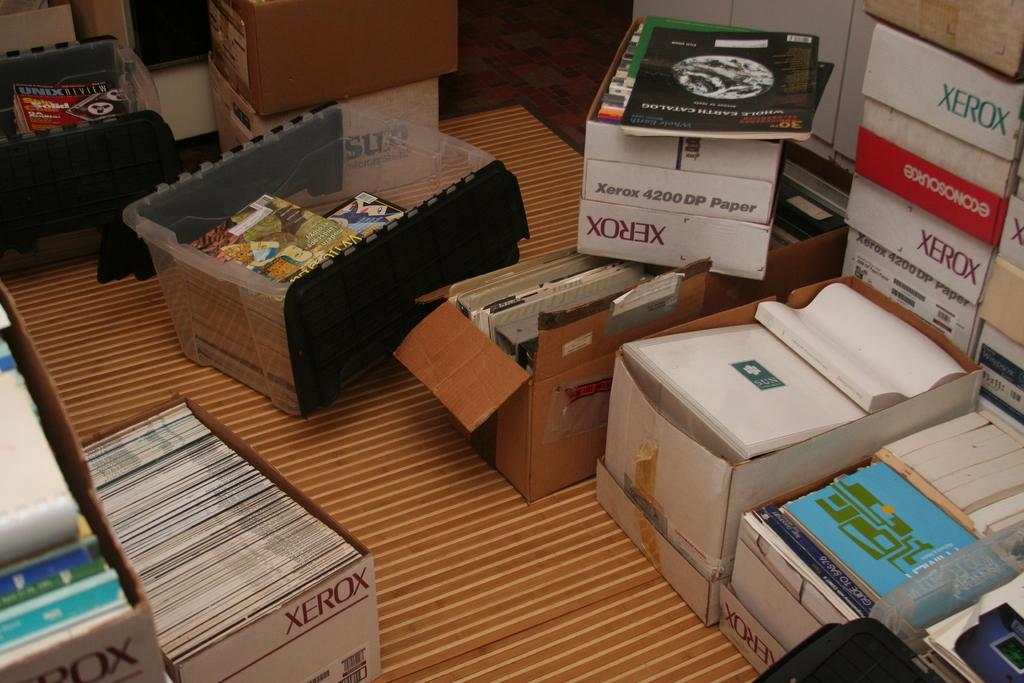<image>
Create a compact narrative representing the image presented. Xerox boxes stacked on top of one another. 